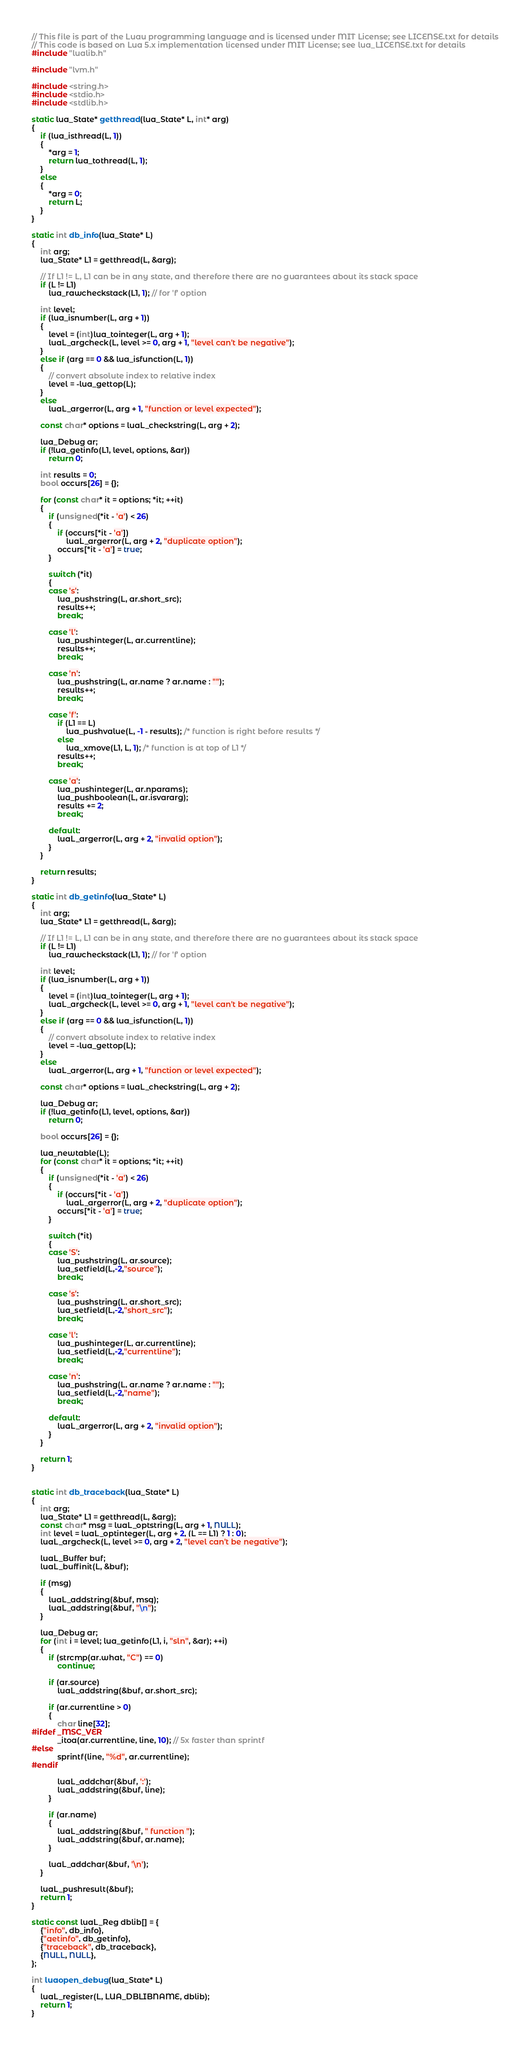<code> <loc_0><loc_0><loc_500><loc_500><_C++_>// This file is part of the Luau programming language and is licensed under MIT License; see LICENSE.txt for details
// This code is based on Lua 5.x implementation licensed under MIT License; see lua_LICENSE.txt for details
#include "lualib.h"

#include "lvm.h"

#include <string.h>
#include <stdio.h>
#include <stdlib.h>

static lua_State* getthread(lua_State* L, int* arg)
{
    if (lua_isthread(L, 1))
    {
        *arg = 1;
        return lua_tothread(L, 1);
    }
    else
    {
        *arg = 0;
        return L;
    }
}

static int db_info(lua_State* L)
{
    int arg;
    lua_State* L1 = getthread(L, &arg);

    // If L1 != L, L1 can be in any state, and therefore there are no guarantees about its stack space
    if (L != L1)
        lua_rawcheckstack(L1, 1); // for 'f' option

    int level;
    if (lua_isnumber(L, arg + 1))
    {
        level = (int)lua_tointeger(L, arg + 1);
        luaL_argcheck(L, level >= 0, arg + 1, "level can't be negative");
    }
    else if (arg == 0 && lua_isfunction(L, 1))
    {
        // convert absolute index to relative index
        level = -lua_gettop(L);
    }
    else
        luaL_argerror(L, arg + 1, "function or level expected");

    const char* options = luaL_checkstring(L, arg + 2);

    lua_Debug ar;
    if (!lua_getinfo(L1, level, options, &ar))
        return 0;

    int results = 0;
    bool occurs[26] = {};

    for (const char* it = options; *it; ++it)
    {
        if (unsigned(*it - 'a') < 26)
        {
            if (occurs[*it - 'a'])
                luaL_argerror(L, arg + 2, "duplicate option");
            occurs[*it - 'a'] = true;
        }

        switch (*it)
        {
        case 's':
            lua_pushstring(L, ar.short_src);
            results++;
            break;

        case 'l':
            lua_pushinteger(L, ar.currentline);
            results++;
            break;

        case 'n':
            lua_pushstring(L, ar.name ? ar.name : "");
            results++;
            break;

        case 'f':
            if (L1 == L)
                lua_pushvalue(L, -1 - results); /* function is right before results */
            else
                lua_xmove(L1, L, 1); /* function is at top of L1 */
            results++;
            break;

        case 'a':
            lua_pushinteger(L, ar.nparams);
            lua_pushboolean(L, ar.isvararg);
            results += 2;
            break;

        default:
            luaL_argerror(L, arg + 2, "invalid option");
        }
    }

    return results;
}

static int db_getinfo(lua_State* L)
{
    int arg;
    lua_State* L1 = getthread(L, &arg);

    // If L1 != L, L1 can be in any state, and therefore there are no guarantees about its stack space
    if (L != L1)
        lua_rawcheckstack(L1, 1); // for 'f' option

    int level;
    if (lua_isnumber(L, arg + 1))
    {
        level = (int)lua_tointeger(L, arg + 1);
        luaL_argcheck(L, level >= 0, arg + 1, "level can't be negative");
    }
    else if (arg == 0 && lua_isfunction(L, 1))
    {
        // convert absolute index to relative index
        level = -lua_gettop(L);
    }
    else
        luaL_argerror(L, arg + 1, "function or level expected");

    const char* options = luaL_checkstring(L, arg + 2);

    lua_Debug ar;
    if (!lua_getinfo(L1, level, options, &ar))
        return 0;

    bool occurs[26] = {};

    lua_newtable(L);
    for (const char* it = options; *it; ++it)
    {
        if (unsigned(*it - 'a') < 26)
        {
            if (occurs[*it - 'a'])
                luaL_argerror(L, arg + 2, "duplicate option");
            occurs[*it - 'a'] = true;
        }

        switch (*it)
        {
        case 'S':
            lua_pushstring(L, ar.source);
            lua_setfield(L,-2,"source");
            break;

        case 's':
            lua_pushstring(L, ar.short_src);
            lua_setfield(L,-2,"short_src");
            break;

        case 'l':
            lua_pushinteger(L, ar.currentline);
            lua_setfield(L,-2,"currentline");
            break;

        case 'n':
            lua_pushstring(L, ar.name ? ar.name : "");
            lua_setfield(L,-2,"name");
            break;

        default:
            luaL_argerror(L, arg + 2, "invalid option");
        }
    }

    return 1;
}


static int db_traceback(lua_State* L)
{
    int arg;
    lua_State* L1 = getthread(L, &arg);
    const char* msg = luaL_optstring(L, arg + 1, NULL);
    int level = luaL_optinteger(L, arg + 2, (L == L1) ? 1 : 0);
    luaL_argcheck(L, level >= 0, arg + 2, "level can't be negative");

    luaL_Buffer buf;
    luaL_buffinit(L, &buf);

    if (msg)
    {
        luaL_addstring(&buf, msg);
        luaL_addstring(&buf, "\n");
    }

    lua_Debug ar;
    for (int i = level; lua_getinfo(L1, i, "sln", &ar); ++i)
    {
        if (strcmp(ar.what, "C") == 0)
            continue;

        if (ar.source)
            luaL_addstring(&buf, ar.short_src);

        if (ar.currentline > 0)
        {
            char line[32];
#ifdef _MSC_VER
            _itoa(ar.currentline, line, 10); // 5x faster than sprintf
#else
            sprintf(line, "%d", ar.currentline);
#endif

            luaL_addchar(&buf, ':');
            luaL_addstring(&buf, line);
        }

        if (ar.name)
        {
            luaL_addstring(&buf, " function ");
            luaL_addstring(&buf, ar.name);
        }

        luaL_addchar(&buf, '\n');
    }

    luaL_pushresult(&buf);
    return 1;
}

static const luaL_Reg dblib[] = {
    {"info", db_info},
    {"getinfo", db_getinfo},
    {"traceback", db_traceback},
    {NULL, NULL},
};

int luaopen_debug(lua_State* L)
{
    luaL_register(L, LUA_DBLIBNAME, dblib);
    return 1;
}
</code> 